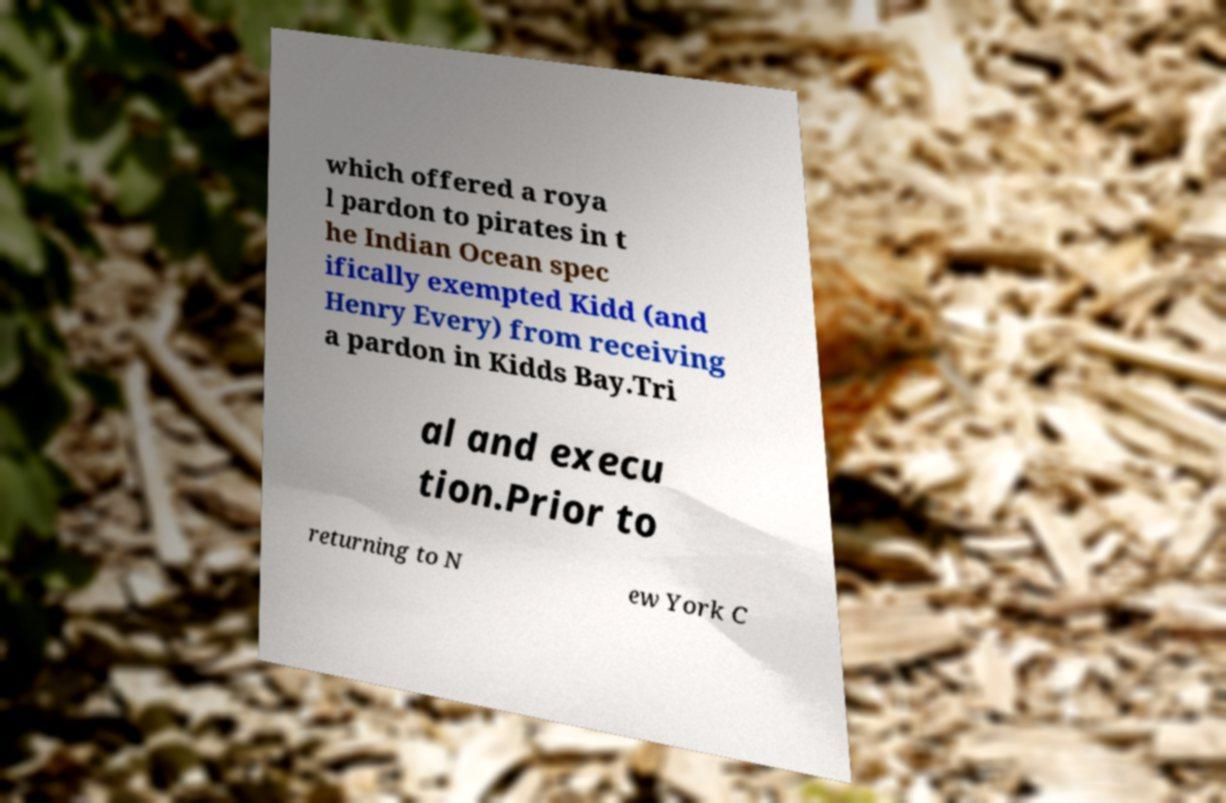What messages or text are displayed in this image? I need them in a readable, typed format. which offered a roya l pardon to pirates in t he Indian Ocean spec ifically exempted Kidd (and Henry Every) from receiving a pardon in Kidds Bay.Tri al and execu tion.Prior to returning to N ew York C 